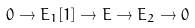Convert formula to latex. <formula><loc_0><loc_0><loc_500><loc_500>0 \to E _ { 1 } [ 1 ] \to E \to E _ { 2 } \to 0</formula> 